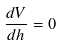Convert formula to latex. <formula><loc_0><loc_0><loc_500><loc_500>\frac { d V } { d h } = 0</formula> 